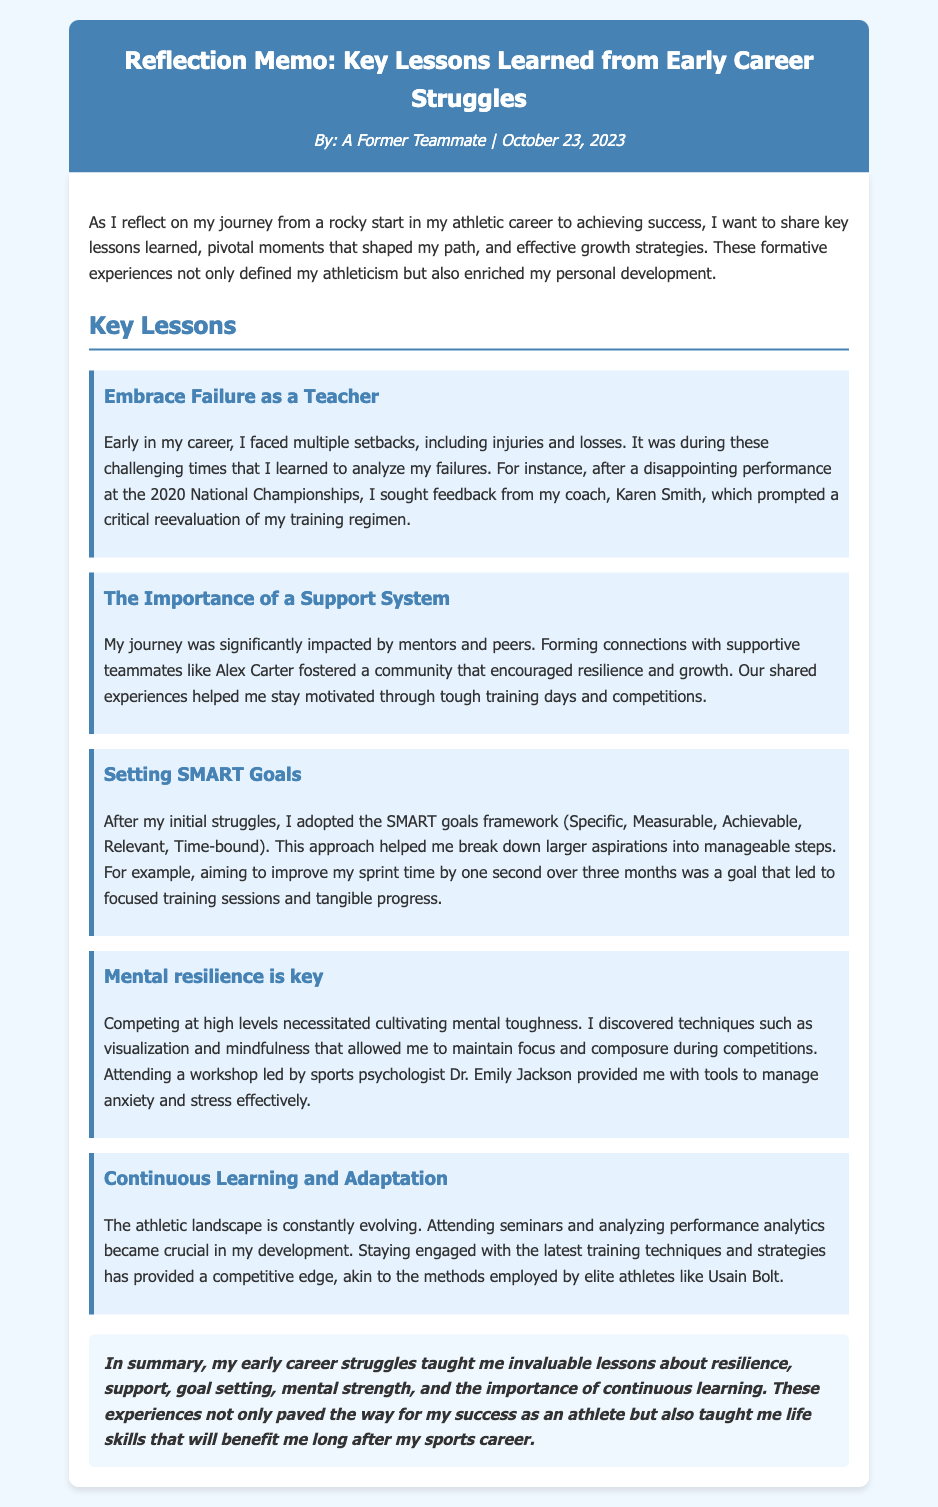What is the title of the memo? The title of the memo is provided in the header, summarizing the document's main focus on reflection and lessons learned.
Answer: Reflection Memo: Key Lessons Learned from Early Career Struggles Who is the author of the memo? The author's name is mentioned in the header, indicating their identity as a former teammate.
Answer: A Former Teammate When was the memo published? The publication date is included in the header, indicating when the reflections were shared.
Answer: October 23, 2023 What is one key lesson learned? The memo outlines multiple lessons, with each lesson prominently highlighted.
Answer: Embrace Failure as a Teacher Who provided critical feedback after a disappointing performance? A specific coach is mentioned within the context of the author's experience and feedback sought after a loss.
Answer: Karen Smith What framework did the author adopt for goal setting? The memo references a famous framework for setting effective goals, which is clearly stated.
Answer: SMART goals What technique helped the author maintain focus during competitions? Techniques used to improve mental focus and resilience are discussed, one of which is named distinctly in the text.
Answer: Visualization What was a pivotal event for the author's reevaluation of training? A specific competition is linked directly to a moment of reflection and change in training methods.
Answer: 2020 National Championships Who conducted a workshop attended by the author? The memo mentions a professional who provided mental health tools through a workshop, marking their influence.
Answer: Dr. Emily Jackson What is emphasized as important for athletic development? The memo highlights a particular ongoing endeavor that is significant to an athlete's growth and competitiveness.
Answer: Continuous Learning and Adaptation 